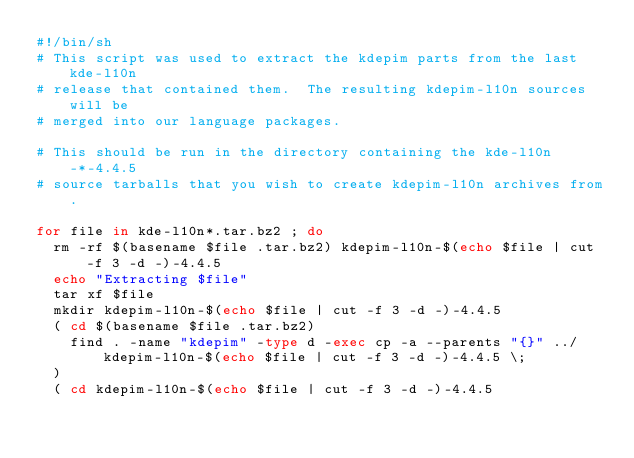Convert code to text. <code><loc_0><loc_0><loc_500><loc_500><_Bash_>#!/bin/sh
# This script was used to extract the kdepim parts from the last kde-l10n
# release that contained them.  The resulting kdepim-l10n sources will be
# merged into our language packages.

# This should be run in the directory containing the kde-l10n-*-4.4.5
# source tarballs that you wish to create kdepim-l10n archives from.

for file in kde-l10n*.tar.bz2 ; do
  rm -rf $(basename $file .tar.bz2) kdepim-l10n-$(echo $file | cut -f 3 -d -)-4.4.5
  echo "Extracting $file"
  tar xf $file
  mkdir kdepim-l10n-$(echo $file | cut -f 3 -d -)-4.4.5
  ( cd $(basename $file .tar.bz2)
    find . -name "kdepim" -type d -exec cp -a --parents "{}" ../kdepim-l10n-$(echo $file | cut -f 3 -d -)-4.4.5 \;
  )
  ( cd kdepim-l10n-$(echo $file | cut -f 3 -d -)-4.4.5</code> 